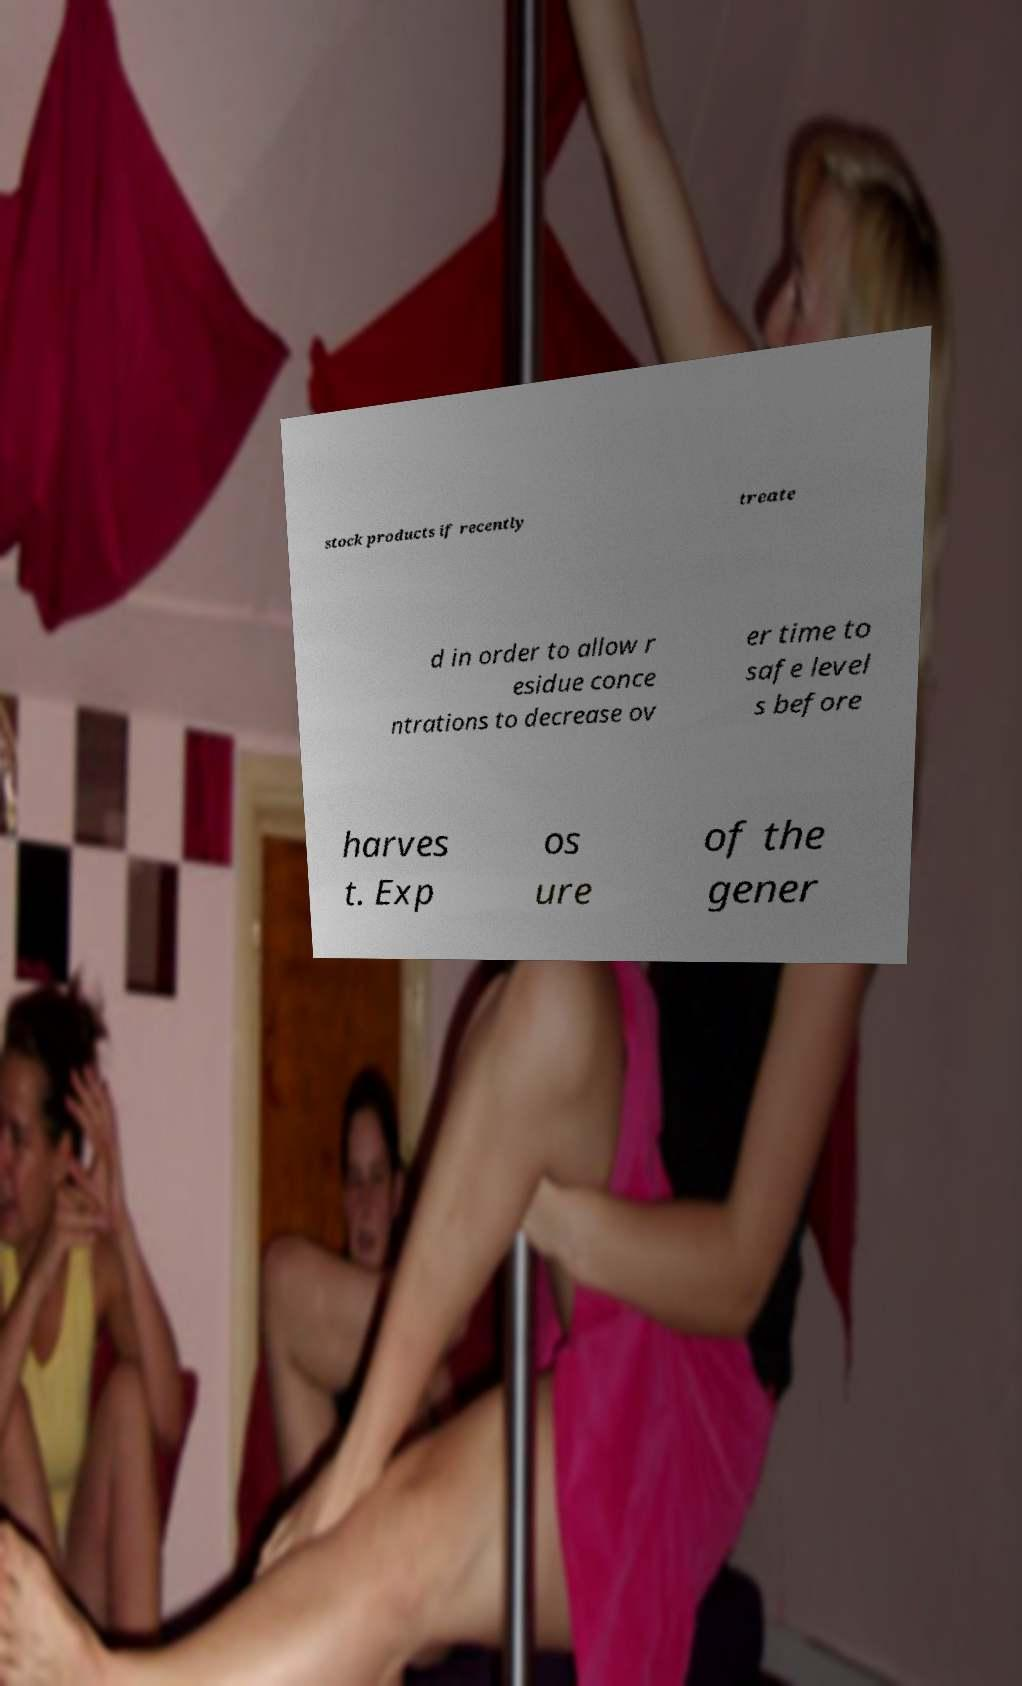Could you assist in decoding the text presented in this image and type it out clearly? stock products if recently treate d in order to allow r esidue conce ntrations to decrease ov er time to safe level s before harves t. Exp os ure of the gener 